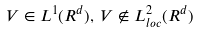<formula> <loc_0><loc_0><loc_500><loc_500>V \in L ^ { 1 } ( { R ^ { d } } ) , \, V \not \in L _ { l o c } ^ { 2 } ( { R ^ { d } } )</formula> 